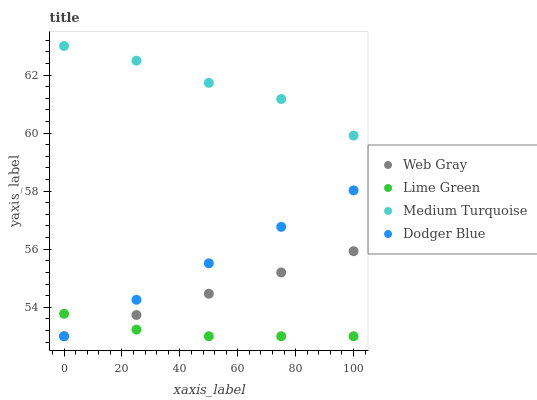Does Lime Green have the minimum area under the curve?
Answer yes or no. Yes. Does Medium Turquoise have the maximum area under the curve?
Answer yes or no. Yes. Does Web Gray have the minimum area under the curve?
Answer yes or no. No. Does Web Gray have the maximum area under the curve?
Answer yes or no. No. Is Web Gray the smoothest?
Answer yes or no. Yes. Is Medium Turquoise the roughest?
Answer yes or no. Yes. Is Lime Green the smoothest?
Answer yes or no. No. Is Lime Green the roughest?
Answer yes or no. No. Does Dodger Blue have the lowest value?
Answer yes or no. Yes. Does Medium Turquoise have the lowest value?
Answer yes or no. No. Does Medium Turquoise have the highest value?
Answer yes or no. Yes. Does Web Gray have the highest value?
Answer yes or no. No. Is Dodger Blue less than Medium Turquoise?
Answer yes or no. Yes. Is Medium Turquoise greater than Lime Green?
Answer yes or no. Yes. Does Lime Green intersect Web Gray?
Answer yes or no. Yes. Is Lime Green less than Web Gray?
Answer yes or no. No. Is Lime Green greater than Web Gray?
Answer yes or no. No. Does Dodger Blue intersect Medium Turquoise?
Answer yes or no. No. 